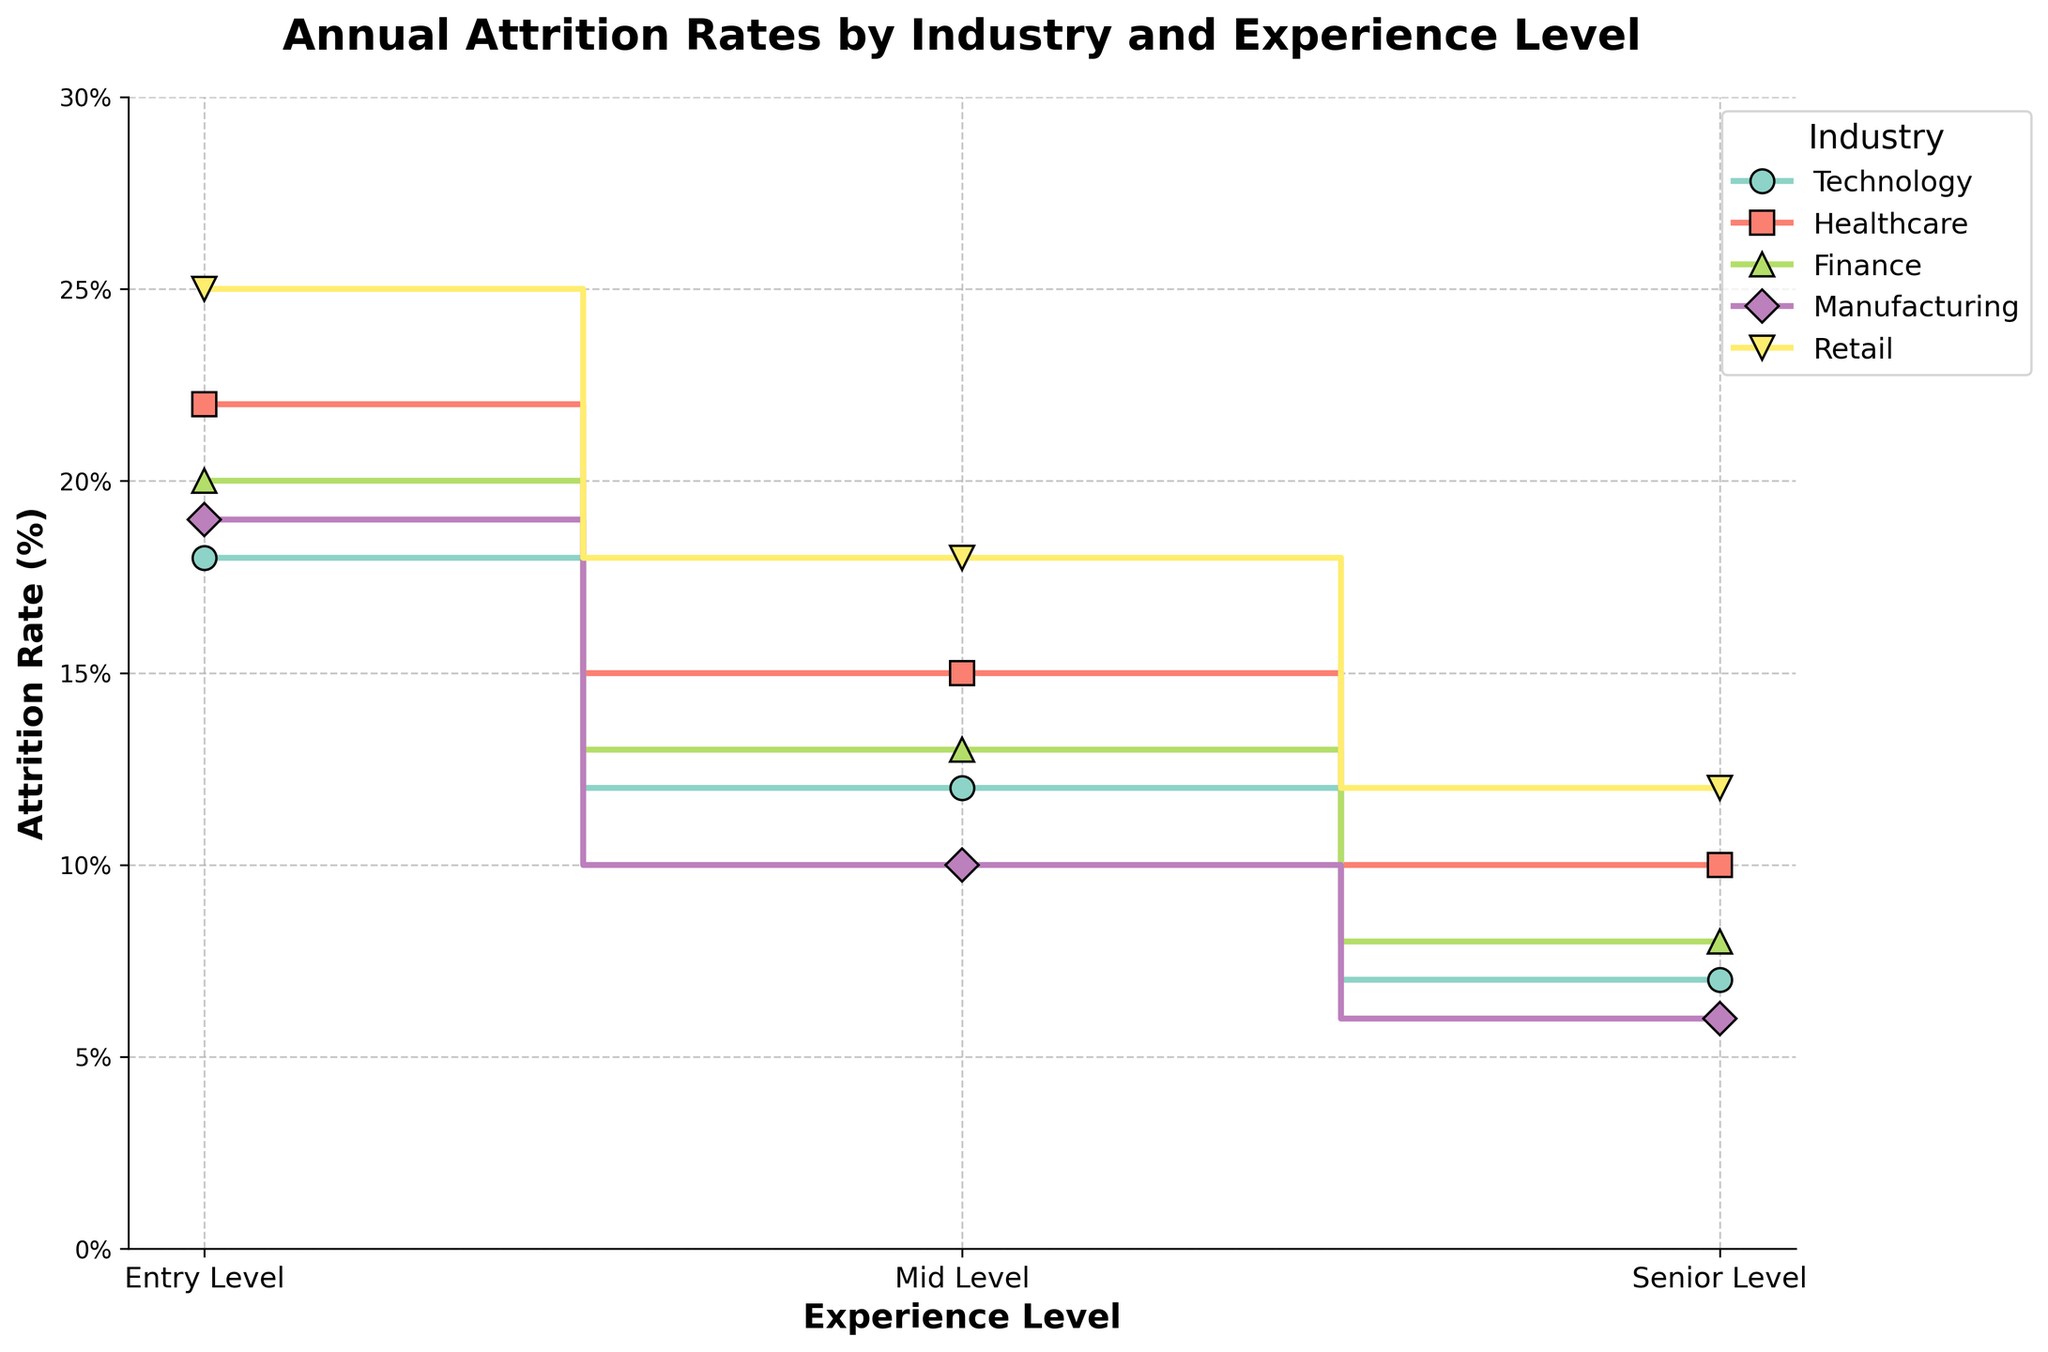What's the title of the figure? The title of the figure is displayed prominently at the top. It is meant to give an overview of what the entire plot represents. In this case, it will describe the subject of the plot.
Answer: Annual Attrition Rates by Industry and Experience Level How does attrition rate change with experience level in the Technology industry? Look for the Technology industry line and observe how the attrition rate varies at different experience levels (Entry, Mid, Senior).
Answer: Decreasing from 18% (Entry) to 7% (Senior) Which industry has the highest entry-level attrition rate? Compare the attrition rates at the entry-level across all industries by looking at the starting point of each industry line.
Answer: Retail What is the difference in senior-level attrition rates between Healthcare and Manufacturing? Find the value of the attrition rate at the senior level for both Healthcare and Manufacturing. Subtract the lower value from the higher value to find the difference.
Answer: 10% - 6% = 4% Which industry has the lowest mid-level attrition rate? Compare the mid-level attrition rates across all industries by looking at the middle segment of each industry line.
Answer: Manufacturing What’s the average attrition rate for each experience level in Finance? Add the attrition rates for each experience level in Finance and divide by the number of experience levels (3).
Answer: (20% + 13% + 8%) / 3 = 13.67% How does the attrition trend in Retail compare to that in Manufacturing across all experience levels? Observe both the Retail and Manufacturing lines across all experience levels and note if they increase or decrease and by how much.
Answer: Retail consistently has higher attrition rates at each level, with both showing a decreasing trend At which experience level does Healthcare have the largest drop in attrition rate? Look at the rate of change in attrition between consecutive experience levels for Healthcare and identify the largest drop.
Answer: From Entry to Mid Level What are the attrition rates for Mid-Level employees in all industries? Identify the attrition rates at the mid-level (the middle segment) for each industry - Technology, Healthcare, Finance, Manufacturing, and Retail.
Answer: Technology: 12%, Healthcare: 15%, Finance: 13%, Manufacturing: 10%, Retail: 18% Which industry has the steepest decline in attrition rates from entry to senior level? Determine the initial and final attrition rates for entry and senior levels for each industry. Calculate the difference and compare them. The industry with the largest difference has the steepest decline.
Answer: Retail (25% - 12% = 13%) 